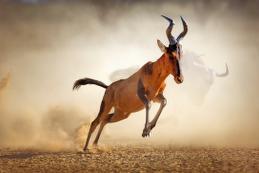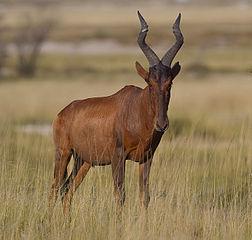The first image is the image on the left, the second image is the image on the right. For the images shown, is this caption "There are two antelopes in the wild." true? Answer yes or no. Yes. The first image is the image on the left, the second image is the image on the right. Examine the images to the left and right. Is the description "An image shows one horned animal standing and facing the camera." accurate? Answer yes or no. Yes. 